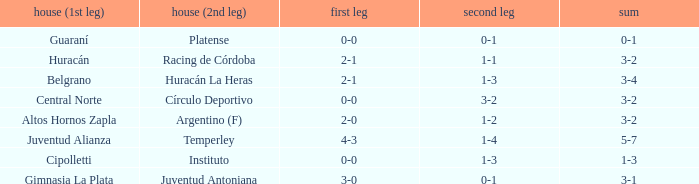Who played at home for the second leg with a score of 0-1 and tied 0-0 in the first leg? Platense. 